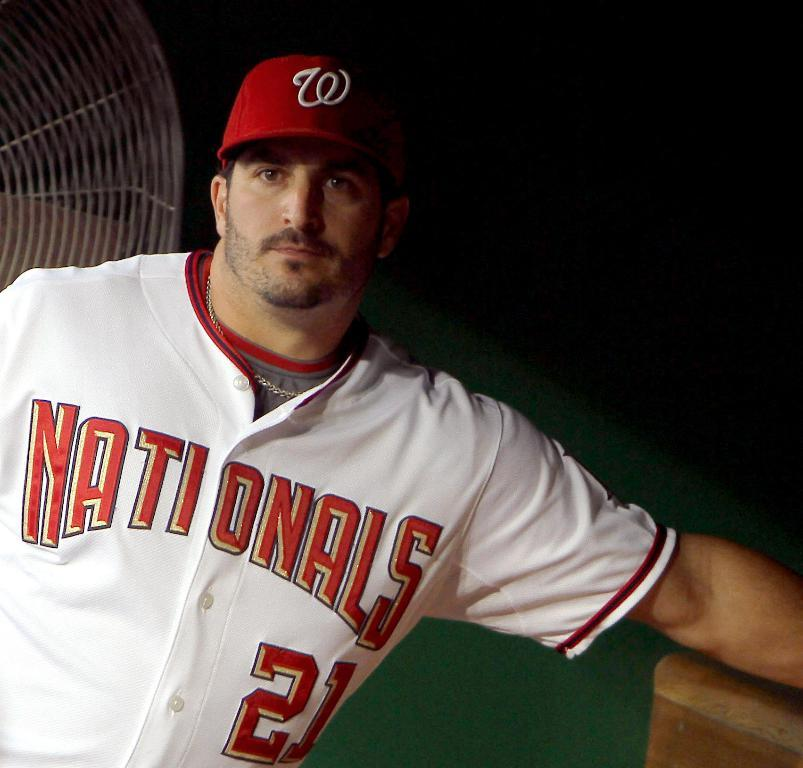Provide a one-sentence caption for the provided image. A player with a Nationals jersey on and a red hat. 